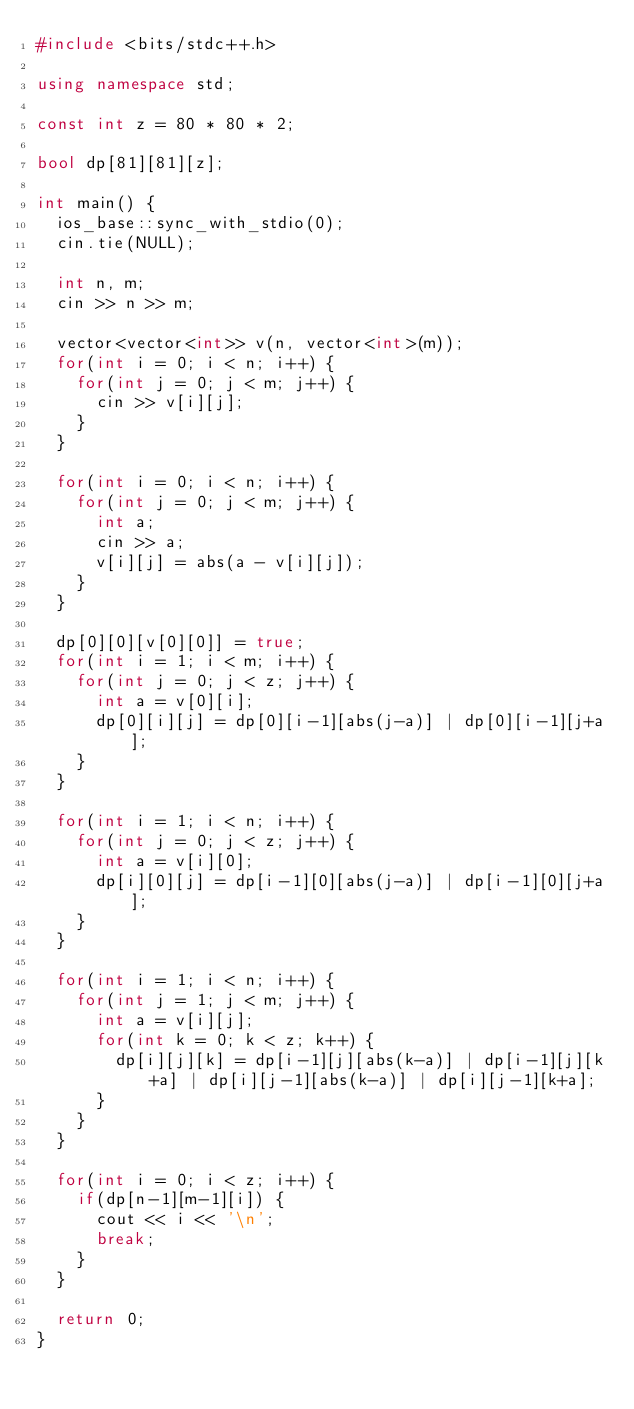Convert code to text. <code><loc_0><loc_0><loc_500><loc_500><_C++_>#include <bits/stdc++.h>
 
using namespace std;

const int z = 80 * 80 * 2;
 
bool dp[81][81][z];
 
int main() {
	ios_base::sync_with_stdio(0);
	cin.tie(NULL);
 
	int n, m;
	cin >> n >> m;
	
	vector<vector<int>> v(n, vector<int>(m));
	for(int i = 0; i < n; i++) {
		for(int j = 0; j < m; j++) {
			cin >> v[i][j];
		}
	}
 
	for(int i = 0; i < n; i++) {
		for(int j = 0; j < m; j++) {
			int a;
			cin >> a;
			v[i][j] = abs(a - v[i][j]);
		}
	}
 
	dp[0][0][v[0][0]] = true;
	for(int i = 1; i < m; i++) {
		for(int j = 0; j < z; j++) {
			int a = v[0][i];
			dp[0][i][j] = dp[0][i-1][abs(j-a)] | dp[0][i-1][j+a];
		}
	}
 
	for(int i = 1; i < n; i++) {
		for(int j = 0; j < z; j++) {
			int a = v[i][0];
			dp[i][0][j] = dp[i-1][0][abs(j-a)] | dp[i-1][0][j+a];
		}
	}
 
	for(int i = 1; i < n; i++) {
		for(int j = 1; j < m; j++) {
			int a = v[i][j];
			for(int k = 0; k < z; k++) {
				dp[i][j][k] = dp[i-1][j][abs(k-a)] | dp[i-1][j][k+a] | dp[i][j-1][abs(k-a)] | dp[i][j-1][k+a];
			}
		}	
	}
 
	for(int i = 0; i < z; i++) {
		if(dp[n-1][m-1][i]) {
			cout << i << '\n';
			break;
		}
	}
 
	return 0;
}</code> 